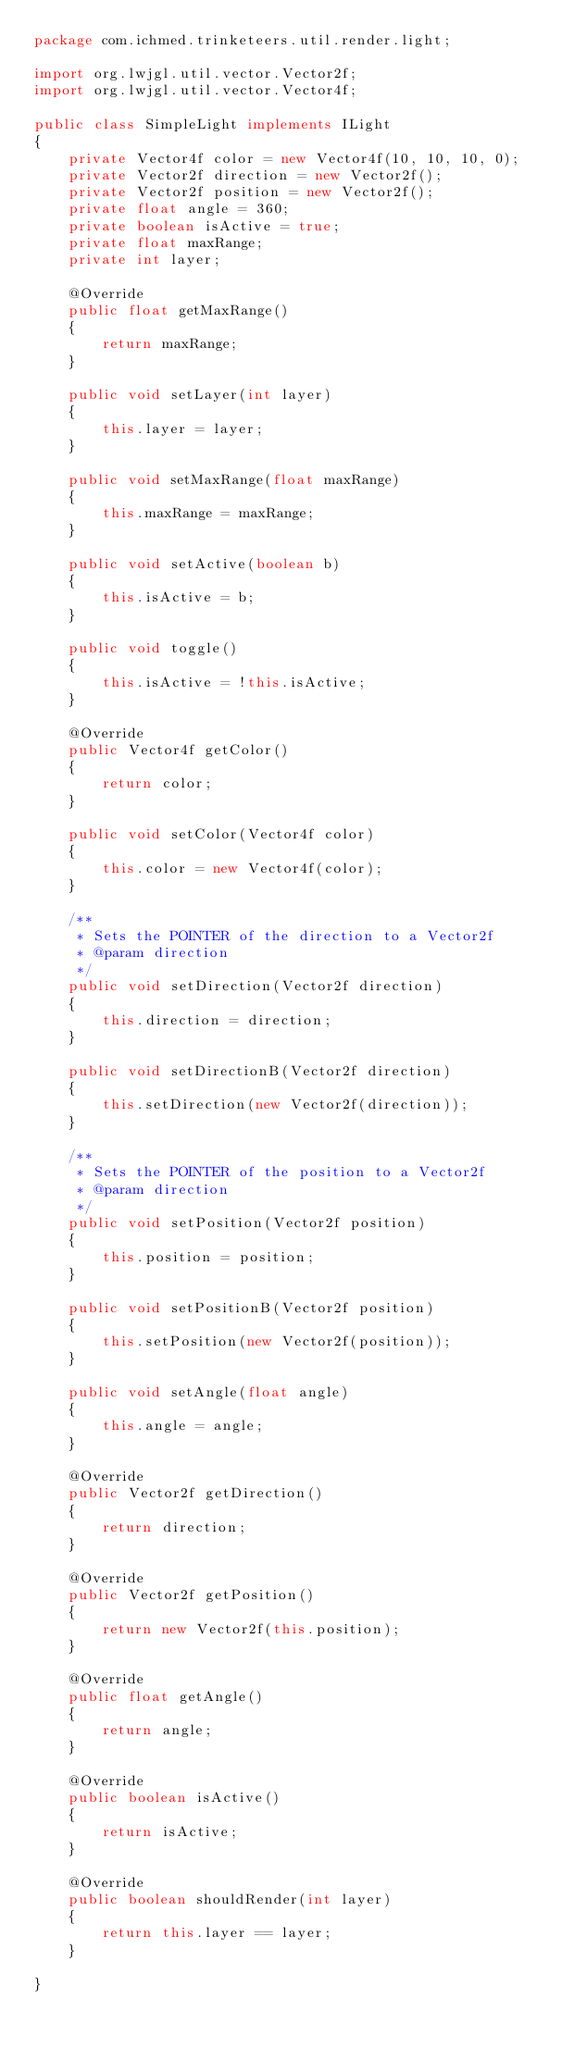Convert code to text. <code><loc_0><loc_0><loc_500><loc_500><_Java_>package com.ichmed.trinketeers.util.render.light;

import org.lwjgl.util.vector.Vector2f;
import org.lwjgl.util.vector.Vector4f;

public class SimpleLight implements ILight
{
	private Vector4f color = new Vector4f(10, 10, 10, 0);
	private Vector2f direction = new Vector2f();
	private Vector2f position = new Vector2f();
	private float angle = 360;
	private boolean isActive = true;
	private float maxRange;
	private int layer;

	@Override
	public float getMaxRange()
	{
		return maxRange;
	}
	
	public void setLayer(int layer)
	{
		this.layer = layer;
	}

	public void setMaxRange(float maxRange)
	{
		this.maxRange = maxRange;
	}

	public void setActive(boolean b)
	{
		this.isActive = b;
	}
	
	public void toggle()
	{
		this.isActive = !this.isActive;
	}

	@Override
	public Vector4f getColor()
	{
		return color;
	}

	public void setColor(Vector4f color)
	{
		this.color = new Vector4f(color);
	}

	/**
	 * Sets the POINTER of the direction to a Vector2f
	 * @param direction
	 */
	public void setDirection(Vector2f direction)
	{
		this.direction = direction;
	}
	
	public void setDirectionB(Vector2f direction)
	{
		this.setDirection(new Vector2f(direction));
	}

	/**
	 * Sets the POINTER of the position to a Vector2f
	 * @param direction
	 */
	public void setPosition(Vector2f position)
	{
		this.position = position;
	}
	
	public void setPositionB(Vector2f position)
	{
		this.setPosition(new Vector2f(position));
	}

	public void setAngle(float angle)
	{
		this.angle = angle;
	}

	@Override
	public Vector2f getDirection()
	{
		return direction;
	}

	@Override
	public Vector2f getPosition()
	{
		return new Vector2f(this.position);
	}

	@Override
	public float getAngle()
	{
		return angle;
	}

	@Override
	public boolean isActive()
	{
		return isActive;
	}

	@Override
	public boolean shouldRender(int layer)
	{
		return this.layer == layer;
	}

}
</code> 